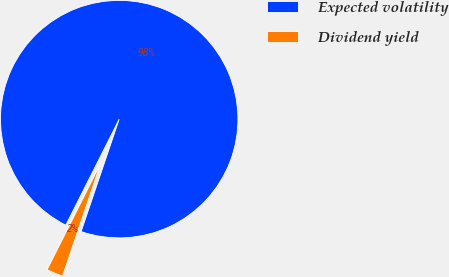Convert chart. <chart><loc_0><loc_0><loc_500><loc_500><pie_chart><fcel>Expected volatility<fcel>Dividend yield<nl><fcel>97.77%<fcel>2.23%<nl></chart> 